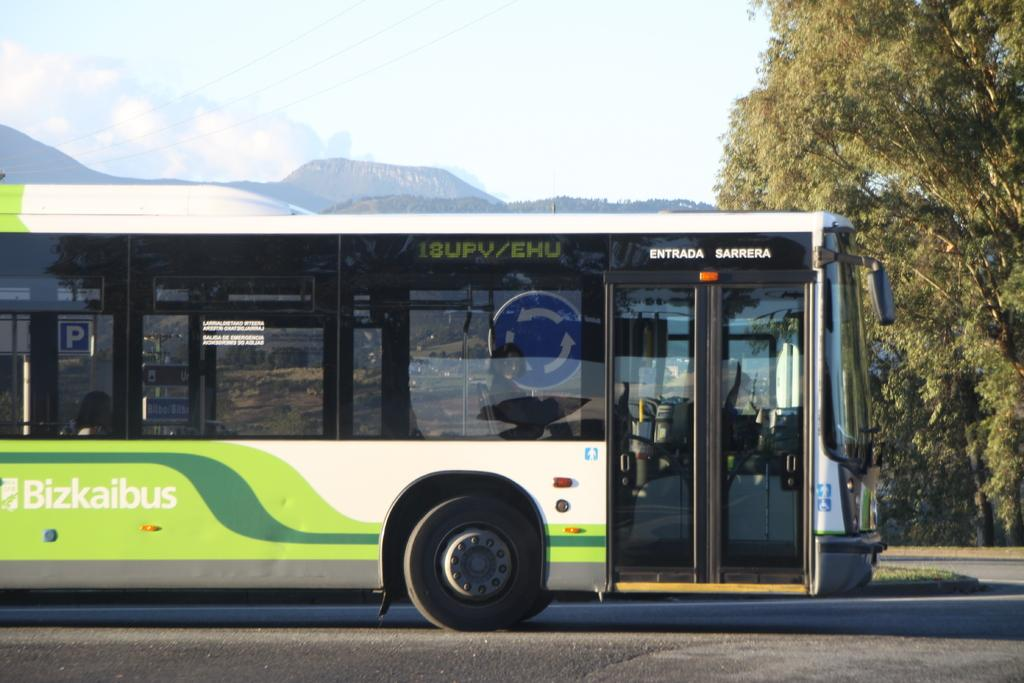<image>
Relay a brief, clear account of the picture shown. The Bizkaibus is used in a foreign country. 